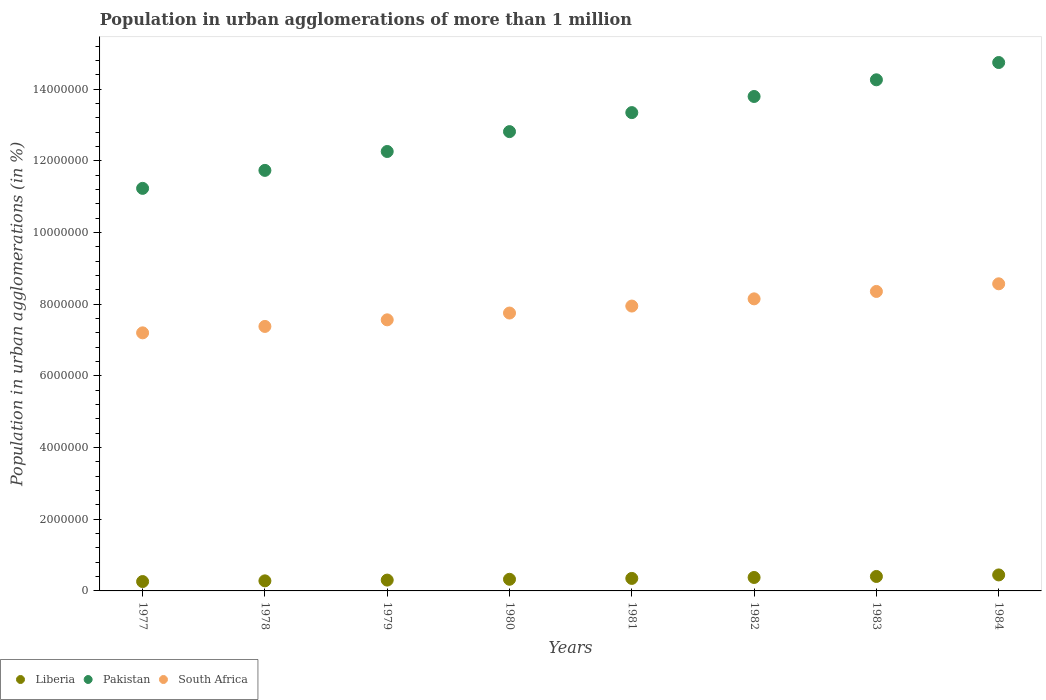What is the population in urban agglomerations in Liberia in 1978?
Ensure brevity in your answer.  2.81e+05. Across all years, what is the maximum population in urban agglomerations in Pakistan?
Your answer should be very brief. 1.47e+07. Across all years, what is the minimum population in urban agglomerations in South Africa?
Your answer should be compact. 7.20e+06. In which year was the population in urban agglomerations in Liberia maximum?
Keep it short and to the point. 1984. In which year was the population in urban agglomerations in South Africa minimum?
Ensure brevity in your answer.  1977. What is the total population in urban agglomerations in South Africa in the graph?
Your answer should be compact. 6.29e+07. What is the difference between the population in urban agglomerations in Pakistan in 1983 and that in 1984?
Your response must be concise. -4.82e+05. What is the difference between the population in urban agglomerations in South Africa in 1983 and the population in urban agglomerations in Liberia in 1977?
Offer a terse response. 8.10e+06. What is the average population in urban agglomerations in Pakistan per year?
Your answer should be very brief. 1.30e+07. In the year 1983, what is the difference between the population in urban agglomerations in Pakistan and population in urban agglomerations in South Africa?
Your answer should be very brief. 5.91e+06. What is the ratio of the population in urban agglomerations in Liberia in 1979 to that in 1982?
Keep it short and to the point. 0.8. Is the difference between the population in urban agglomerations in Pakistan in 1980 and 1983 greater than the difference between the population in urban agglomerations in South Africa in 1980 and 1983?
Your answer should be compact. No. What is the difference between the highest and the second highest population in urban agglomerations in South Africa?
Ensure brevity in your answer.  2.13e+05. What is the difference between the highest and the lowest population in urban agglomerations in South Africa?
Provide a succinct answer. 1.37e+06. In how many years, is the population in urban agglomerations in Liberia greater than the average population in urban agglomerations in Liberia taken over all years?
Offer a very short reply. 4. Is the sum of the population in urban agglomerations in Liberia in 1977 and 1978 greater than the maximum population in urban agglomerations in South Africa across all years?
Your answer should be very brief. No. Is it the case that in every year, the sum of the population in urban agglomerations in South Africa and population in urban agglomerations in Pakistan  is greater than the population in urban agglomerations in Liberia?
Offer a terse response. Yes. How many years are there in the graph?
Your response must be concise. 8. What is the difference between two consecutive major ticks on the Y-axis?
Ensure brevity in your answer.  2.00e+06. Does the graph contain any zero values?
Provide a succinct answer. No. How many legend labels are there?
Make the answer very short. 3. What is the title of the graph?
Provide a succinct answer. Population in urban agglomerations of more than 1 million. Does "Gambia, The" appear as one of the legend labels in the graph?
Provide a short and direct response. No. What is the label or title of the X-axis?
Your response must be concise. Years. What is the label or title of the Y-axis?
Ensure brevity in your answer.  Population in urban agglomerations (in %). What is the Population in urban agglomerations (in %) of Liberia in 1977?
Offer a very short reply. 2.61e+05. What is the Population in urban agglomerations (in %) in Pakistan in 1977?
Provide a succinct answer. 1.12e+07. What is the Population in urban agglomerations (in %) of South Africa in 1977?
Provide a succinct answer. 7.20e+06. What is the Population in urban agglomerations (in %) of Liberia in 1978?
Give a very brief answer. 2.81e+05. What is the Population in urban agglomerations (in %) of Pakistan in 1978?
Your answer should be compact. 1.17e+07. What is the Population in urban agglomerations (in %) in South Africa in 1978?
Provide a succinct answer. 7.38e+06. What is the Population in urban agglomerations (in %) of Liberia in 1979?
Your response must be concise. 3.02e+05. What is the Population in urban agglomerations (in %) in Pakistan in 1979?
Provide a short and direct response. 1.23e+07. What is the Population in urban agglomerations (in %) in South Africa in 1979?
Offer a very short reply. 7.56e+06. What is the Population in urban agglomerations (in %) of Liberia in 1980?
Keep it short and to the point. 3.25e+05. What is the Population in urban agglomerations (in %) in Pakistan in 1980?
Give a very brief answer. 1.28e+07. What is the Population in urban agglomerations (in %) in South Africa in 1980?
Offer a terse response. 7.75e+06. What is the Population in urban agglomerations (in %) of Liberia in 1981?
Make the answer very short. 3.49e+05. What is the Population in urban agglomerations (in %) of Pakistan in 1981?
Ensure brevity in your answer.  1.33e+07. What is the Population in urban agglomerations (in %) in South Africa in 1981?
Your answer should be compact. 7.95e+06. What is the Population in urban agglomerations (in %) in Liberia in 1982?
Make the answer very short. 3.75e+05. What is the Population in urban agglomerations (in %) in Pakistan in 1982?
Offer a terse response. 1.38e+07. What is the Population in urban agglomerations (in %) of South Africa in 1982?
Your answer should be very brief. 8.15e+06. What is the Population in urban agglomerations (in %) in Liberia in 1983?
Your answer should be compact. 4.03e+05. What is the Population in urban agglomerations (in %) in Pakistan in 1983?
Provide a succinct answer. 1.43e+07. What is the Population in urban agglomerations (in %) in South Africa in 1983?
Give a very brief answer. 8.36e+06. What is the Population in urban agglomerations (in %) in Liberia in 1984?
Ensure brevity in your answer.  4.46e+05. What is the Population in urban agglomerations (in %) in Pakistan in 1984?
Ensure brevity in your answer.  1.47e+07. What is the Population in urban agglomerations (in %) in South Africa in 1984?
Your answer should be compact. 8.57e+06. Across all years, what is the maximum Population in urban agglomerations (in %) of Liberia?
Provide a short and direct response. 4.46e+05. Across all years, what is the maximum Population in urban agglomerations (in %) in Pakistan?
Provide a succinct answer. 1.47e+07. Across all years, what is the maximum Population in urban agglomerations (in %) of South Africa?
Your answer should be compact. 8.57e+06. Across all years, what is the minimum Population in urban agglomerations (in %) of Liberia?
Keep it short and to the point. 2.61e+05. Across all years, what is the minimum Population in urban agglomerations (in %) in Pakistan?
Give a very brief answer. 1.12e+07. Across all years, what is the minimum Population in urban agglomerations (in %) in South Africa?
Keep it short and to the point. 7.20e+06. What is the total Population in urban agglomerations (in %) of Liberia in the graph?
Your answer should be very brief. 2.74e+06. What is the total Population in urban agglomerations (in %) of Pakistan in the graph?
Ensure brevity in your answer.  1.04e+08. What is the total Population in urban agglomerations (in %) of South Africa in the graph?
Provide a short and direct response. 6.29e+07. What is the difference between the Population in urban agglomerations (in %) in Liberia in 1977 and that in 1978?
Keep it short and to the point. -1.96e+04. What is the difference between the Population in urban agglomerations (in %) of Pakistan in 1977 and that in 1978?
Provide a succinct answer. -5.02e+05. What is the difference between the Population in urban agglomerations (in %) of South Africa in 1977 and that in 1978?
Keep it short and to the point. -1.79e+05. What is the difference between the Population in urban agglomerations (in %) of Liberia in 1977 and that in 1979?
Your response must be concise. -4.07e+04. What is the difference between the Population in urban agglomerations (in %) of Pakistan in 1977 and that in 1979?
Offer a very short reply. -1.03e+06. What is the difference between the Population in urban agglomerations (in %) in South Africa in 1977 and that in 1979?
Your answer should be very brief. -3.63e+05. What is the difference between the Population in urban agglomerations (in %) of Liberia in 1977 and that in 1980?
Offer a terse response. -6.34e+04. What is the difference between the Population in urban agglomerations (in %) in Pakistan in 1977 and that in 1980?
Your answer should be compact. -1.58e+06. What is the difference between the Population in urban agglomerations (in %) of South Africa in 1977 and that in 1980?
Your response must be concise. -5.53e+05. What is the difference between the Population in urban agglomerations (in %) in Liberia in 1977 and that in 1981?
Give a very brief answer. -8.77e+04. What is the difference between the Population in urban agglomerations (in %) of Pakistan in 1977 and that in 1981?
Offer a very short reply. -2.11e+06. What is the difference between the Population in urban agglomerations (in %) in South Africa in 1977 and that in 1981?
Your answer should be very brief. -7.48e+05. What is the difference between the Population in urban agglomerations (in %) in Liberia in 1977 and that in 1982?
Your response must be concise. -1.14e+05. What is the difference between the Population in urban agglomerations (in %) in Pakistan in 1977 and that in 1982?
Provide a succinct answer. -2.56e+06. What is the difference between the Population in urban agglomerations (in %) in South Africa in 1977 and that in 1982?
Ensure brevity in your answer.  -9.49e+05. What is the difference between the Population in urban agglomerations (in %) in Liberia in 1977 and that in 1983?
Your answer should be very brief. -1.42e+05. What is the difference between the Population in urban agglomerations (in %) of Pakistan in 1977 and that in 1983?
Your answer should be compact. -3.03e+06. What is the difference between the Population in urban agglomerations (in %) of South Africa in 1977 and that in 1983?
Your answer should be very brief. -1.16e+06. What is the difference between the Population in urban agglomerations (in %) in Liberia in 1977 and that in 1984?
Provide a short and direct response. -1.85e+05. What is the difference between the Population in urban agglomerations (in %) in Pakistan in 1977 and that in 1984?
Offer a very short reply. -3.51e+06. What is the difference between the Population in urban agglomerations (in %) in South Africa in 1977 and that in 1984?
Offer a terse response. -1.37e+06. What is the difference between the Population in urban agglomerations (in %) in Liberia in 1978 and that in 1979?
Offer a terse response. -2.11e+04. What is the difference between the Population in urban agglomerations (in %) in Pakistan in 1978 and that in 1979?
Keep it short and to the point. -5.27e+05. What is the difference between the Population in urban agglomerations (in %) in South Africa in 1978 and that in 1979?
Your answer should be very brief. -1.84e+05. What is the difference between the Population in urban agglomerations (in %) of Liberia in 1978 and that in 1980?
Ensure brevity in your answer.  -4.38e+04. What is the difference between the Population in urban agglomerations (in %) of Pakistan in 1978 and that in 1980?
Make the answer very short. -1.08e+06. What is the difference between the Population in urban agglomerations (in %) in South Africa in 1978 and that in 1980?
Provide a succinct answer. -3.74e+05. What is the difference between the Population in urban agglomerations (in %) of Liberia in 1978 and that in 1981?
Offer a terse response. -6.81e+04. What is the difference between the Population in urban agglomerations (in %) of Pakistan in 1978 and that in 1981?
Ensure brevity in your answer.  -1.61e+06. What is the difference between the Population in urban agglomerations (in %) of South Africa in 1978 and that in 1981?
Make the answer very short. -5.69e+05. What is the difference between the Population in urban agglomerations (in %) of Liberia in 1978 and that in 1982?
Provide a succinct answer. -9.43e+04. What is the difference between the Population in urban agglomerations (in %) in Pakistan in 1978 and that in 1982?
Provide a short and direct response. -2.06e+06. What is the difference between the Population in urban agglomerations (in %) in South Africa in 1978 and that in 1982?
Provide a succinct answer. -7.70e+05. What is the difference between the Population in urban agglomerations (in %) in Liberia in 1978 and that in 1983?
Provide a short and direct response. -1.22e+05. What is the difference between the Population in urban agglomerations (in %) of Pakistan in 1978 and that in 1983?
Ensure brevity in your answer.  -2.53e+06. What is the difference between the Population in urban agglomerations (in %) of South Africa in 1978 and that in 1983?
Your answer should be very brief. -9.76e+05. What is the difference between the Population in urban agglomerations (in %) of Liberia in 1978 and that in 1984?
Give a very brief answer. -1.65e+05. What is the difference between the Population in urban agglomerations (in %) in Pakistan in 1978 and that in 1984?
Your response must be concise. -3.01e+06. What is the difference between the Population in urban agglomerations (in %) in South Africa in 1978 and that in 1984?
Offer a very short reply. -1.19e+06. What is the difference between the Population in urban agglomerations (in %) in Liberia in 1979 and that in 1980?
Keep it short and to the point. -2.27e+04. What is the difference between the Population in urban agglomerations (in %) of Pakistan in 1979 and that in 1980?
Provide a short and direct response. -5.55e+05. What is the difference between the Population in urban agglomerations (in %) in South Africa in 1979 and that in 1980?
Offer a terse response. -1.90e+05. What is the difference between the Population in urban agglomerations (in %) of Liberia in 1979 and that in 1981?
Offer a terse response. -4.70e+04. What is the difference between the Population in urban agglomerations (in %) in Pakistan in 1979 and that in 1981?
Offer a very short reply. -1.09e+06. What is the difference between the Population in urban agglomerations (in %) of South Africa in 1979 and that in 1981?
Offer a terse response. -3.85e+05. What is the difference between the Population in urban agglomerations (in %) in Liberia in 1979 and that in 1982?
Your answer should be compact. -7.32e+04. What is the difference between the Population in urban agglomerations (in %) in Pakistan in 1979 and that in 1982?
Offer a very short reply. -1.54e+06. What is the difference between the Population in urban agglomerations (in %) in South Africa in 1979 and that in 1982?
Offer a very short reply. -5.85e+05. What is the difference between the Population in urban agglomerations (in %) in Liberia in 1979 and that in 1983?
Your response must be concise. -1.01e+05. What is the difference between the Population in urban agglomerations (in %) of Pakistan in 1979 and that in 1983?
Offer a terse response. -2.00e+06. What is the difference between the Population in urban agglomerations (in %) of South Africa in 1979 and that in 1983?
Provide a short and direct response. -7.92e+05. What is the difference between the Population in urban agglomerations (in %) in Liberia in 1979 and that in 1984?
Provide a succinct answer. -1.44e+05. What is the difference between the Population in urban agglomerations (in %) of Pakistan in 1979 and that in 1984?
Your response must be concise. -2.48e+06. What is the difference between the Population in urban agglomerations (in %) of South Africa in 1979 and that in 1984?
Provide a succinct answer. -1.01e+06. What is the difference between the Population in urban agglomerations (in %) in Liberia in 1980 and that in 1981?
Give a very brief answer. -2.43e+04. What is the difference between the Population in urban agglomerations (in %) in Pakistan in 1980 and that in 1981?
Provide a short and direct response. -5.31e+05. What is the difference between the Population in urban agglomerations (in %) in South Africa in 1980 and that in 1981?
Ensure brevity in your answer.  -1.95e+05. What is the difference between the Population in urban agglomerations (in %) in Liberia in 1980 and that in 1982?
Provide a succinct answer. -5.05e+04. What is the difference between the Population in urban agglomerations (in %) in Pakistan in 1980 and that in 1982?
Your answer should be compact. -9.81e+05. What is the difference between the Population in urban agglomerations (in %) in South Africa in 1980 and that in 1982?
Give a very brief answer. -3.96e+05. What is the difference between the Population in urban agglomerations (in %) of Liberia in 1980 and that in 1983?
Your response must be concise. -7.87e+04. What is the difference between the Population in urban agglomerations (in %) of Pakistan in 1980 and that in 1983?
Offer a terse response. -1.45e+06. What is the difference between the Population in urban agglomerations (in %) of South Africa in 1980 and that in 1983?
Provide a succinct answer. -6.02e+05. What is the difference between the Population in urban agglomerations (in %) in Liberia in 1980 and that in 1984?
Provide a short and direct response. -1.22e+05. What is the difference between the Population in urban agglomerations (in %) in Pakistan in 1980 and that in 1984?
Your answer should be very brief. -1.93e+06. What is the difference between the Population in urban agglomerations (in %) in South Africa in 1980 and that in 1984?
Your response must be concise. -8.16e+05. What is the difference between the Population in urban agglomerations (in %) of Liberia in 1981 and that in 1982?
Give a very brief answer. -2.62e+04. What is the difference between the Population in urban agglomerations (in %) in Pakistan in 1981 and that in 1982?
Your answer should be compact. -4.50e+05. What is the difference between the Population in urban agglomerations (in %) in South Africa in 1981 and that in 1982?
Give a very brief answer. -2.01e+05. What is the difference between the Population in urban agglomerations (in %) of Liberia in 1981 and that in 1983?
Ensure brevity in your answer.  -5.44e+04. What is the difference between the Population in urban agglomerations (in %) of Pakistan in 1981 and that in 1983?
Offer a very short reply. -9.15e+05. What is the difference between the Population in urban agglomerations (in %) of South Africa in 1981 and that in 1983?
Your answer should be compact. -4.08e+05. What is the difference between the Population in urban agglomerations (in %) of Liberia in 1981 and that in 1984?
Keep it short and to the point. -9.72e+04. What is the difference between the Population in urban agglomerations (in %) of Pakistan in 1981 and that in 1984?
Give a very brief answer. -1.40e+06. What is the difference between the Population in urban agglomerations (in %) in South Africa in 1981 and that in 1984?
Give a very brief answer. -6.21e+05. What is the difference between the Population in urban agglomerations (in %) of Liberia in 1982 and that in 1983?
Ensure brevity in your answer.  -2.82e+04. What is the difference between the Population in urban agglomerations (in %) of Pakistan in 1982 and that in 1983?
Your answer should be compact. -4.65e+05. What is the difference between the Population in urban agglomerations (in %) of South Africa in 1982 and that in 1983?
Provide a succinct answer. -2.07e+05. What is the difference between the Population in urban agglomerations (in %) of Liberia in 1982 and that in 1984?
Offer a terse response. -7.10e+04. What is the difference between the Population in urban agglomerations (in %) of Pakistan in 1982 and that in 1984?
Ensure brevity in your answer.  -9.47e+05. What is the difference between the Population in urban agglomerations (in %) of South Africa in 1982 and that in 1984?
Make the answer very short. -4.20e+05. What is the difference between the Population in urban agglomerations (in %) in Liberia in 1983 and that in 1984?
Keep it short and to the point. -4.28e+04. What is the difference between the Population in urban agglomerations (in %) in Pakistan in 1983 and that in 1984?
Provide a succinct answer. -4.82e+05. What is the difference between the Population in urban agglomerations (in %) in South Africa in 1983 and that in 1984?
Ensure brevity in your answer.  -2.13e+05. What is the difference between the Population in urban agglomerations (in %) of Liberia in 1977 and the Population in urban agglomerations (in %) of Pakistan in 1978?
Make the answer very short. -1.15e+07. What is the difference between the Population in urban agglomerations (in %) in Liberia in 1977 and the Population in urban agglomerations (in %) in South Africa in 1978?
Ensure brevity in your answer.  -7.12e+06. What is the difference between the Population in urban agglomerations (in %) in Pakistan in 1977 and the Population in urban agglomerations (in %) in South Africa in 1978?
Keep it short and to the point. 3.85e+06. What is the difference between the Population in urban agglomerations (in %) in Liberia in 1977 and the Population in urban agglomerations (in %) in Pakistan in 1979?
Keep it short and to the point. -1.20e+07. What is the difference between the Population in urban agglomerations (in %) of Liberia in 1977 and the Population in urban agglomerations (in %) of South Africa in 1979?
Your answer should be compact. -7.30e+06. What is the difference between the Population in urban agglomerations (in %) in Pakistan in 1977 and the Population in urban agglomerations (in %) in South Africa in 1979?
Offer a terse response. 3.67e+06. What is the difference between the Population in urban agglomerations (in %) of Liberia in 1977 and the Population in urban agglomerations (in %) of Pakistan in 1980?
Provide a short and direct response. -1.26e+07. What is the difference between the Population in urban agglomerations (in %) in Liberia in 1977 and the Population in urban agglomerations (in %) in South Africa in 1980?
Ensure brevity in your answer.  -7.49e+06. What is the difference between the Population in urban agglomerations (in %) in Pakistan in 1977 and the Population in urban agglomerations (in %) in South Africa in 1980?
Your answer should be compact. 3.48e+06. What is the difference between the Population in urban agglomerations (in %) in Liberia in 1977 and the Population in urban agglomerations (in %) in Pakistan in 1981?
Provide a short and direct response. -1.31e+07. What is the difference between the Population in urban agglomerations (in %) in Liberia in 1977 and the Population in urban agglomerations (in %) in South Africa in 1981?
Provide a succinct answer. -7.69e+06. What is the difference between the Population in urban agglomerations (in %) of Pakistan in 1977 and the Population in urban agglomerations (in %) of South Africa in 1981?
Your answer should be very brief. 3.28e+06. What is the difference between the Population in urban agglomerations (in %) of Liberia in 1977 and the Population in urban agglomerations (in %) of Pakistan in 1982?
Your answer should be compact. -1.35e+07. What is the difference between the Population in urban agglomerations (in %) of Liberia in 1977 and the Population in urban agglomerations (in %) of South Africa in 1982?
Your response must be concise. -7.89e+06. What is the difference between the Population in urban agglomerations (in %) in Pakistan in 1977 and the Population in urban agglomerations (in %) in South Africa in 1982?
Ensure brevity in your answer.  3.08e+06. What is the difference between the Population in urban agglomerations (in %) in Liberia in 1977 and the Population in urban agglomerations (in %) in Pakistan in 1983?
Your answer should be very brief. -1.40e+07. What is the difference between the Population in urban agglomerations (in %) in Liberia in 1977 and the Population in urban agglomerations (in %) in South Africa in 1983?
Offer a terse response. -8.10e+06. What is the difference between the Population in urban agglomerations (in %) in Pakistan in 1977 and the Population in urban agglomerations (in %) in South Africa in 1983?
Make the answer very short. 2.88e+06. What is the difference between the Population in urban agglomerations (in %) in Liberia in 1977 and the Population in urban agglomerations (in %) in Pakistan in 1984?
Your answer should be compact. -1.45e+07. What is the difference between the Population in urban agglomerations (in %) of Liberia in 1977 and the Population in urban agglomerations (in %) of South Africa in 1984?
Your answer should be very brief. -8.31e+06. What is the difference between the Population in urban agglomerations (in %) in Pakistan in 1977 and the Population in urban agglomerations (in %) in South Africa in 1984?
Your answer should be compact. 2.66e+06. What is the difference between the Population in urban agglomerations (in %) of Liberia in 1978 and the Population in urban agglomerations (in %) of Pakistan in 1979?
Ensure brevity in your answer.  -1.20e+07. What is the difference between the Population in urban agglomerations (in %) of Liberia in 1978 and the Population in urban agglomerations (in %) of South Africa in 1979?
Provide a short and direct response. -7.28e+06. What is the difference between the Population in urban agglomerations (in %) of Pakistan in 1978 and the Population in urban agglomerations (in %) of South Africa in 1979?
Your answer should be compact. 4.17e+06. What is the difference between the Population in urban agglomerations (in %) in Liberia in 1978 and the Population in urban agglomerations (in %) in Pakistan in 1980?
Your answer should be very brief. -1.25e+07. What is the difference between the Population in urban agglomerations (in %) in Liberia in 1978 and the Population in urban agglomerations (in %) in South Africa in 1980?
Make the answer very short. -7.47e+06. What is the difference between the Population in urban agglomerations (in %) in Pakistan in 1978 and the Population in urban agglomerations (in %) in South Africa in 1980?
Ensure brevity in your answer.  3.98e+06. What is the difference between the Population in urban agglomerations (in %) of Liberia in 1978 and the Population in urban agglomerations (in %) of Pakistan in 1981?
Ensure brevity in your answer.  -1.31e+07. What is the difference between the Population in urban agglomerations (in %) in Liberia in 1978 and the Population in urban agglomerations (in %) in South Africa in 1981?
Give a very brief answer. -7.67e+06. What is the difference between the Population in urban agglomerations (in %) of Pakistan in 1978 and the Population in urban agglomerations (in %) of South Africa in 1981?
Make the answer very short. 3.79e+06. What is the difference between the Population in urban agglomerations (in %) of Liberia in 1978 and the Population in urban agglomerations (in %) of Pakistan in 1982?
Offer a terse response. -1.35e+07. What is the difference between the Population in urban agglomerations (in %) of Liberia in 1978 and the Population in urban agglomerations (in %) of South Africa in 1982?
Your answer should be very brief. -7.87e+06. What is the difference between the Population in urban agglomerations (in %) of Pakistan in 1978 and the Population in urban agglomerations (in %) of South Africa in 1982?
Make the answer very short. 3.59e+06. What is the difference between the Population in urban agglomerations (in %) of Liberia in 1978 and the Population in urban agglomerations (in %) of Pakistan in 1983?
Make the answer very short. -1.40e+07. What is the difference between the Population in urban agglomerations (in %) in Liberia in 1978 and the Population in urban agglomerations (in %) in South Africa in 1983?
Make the answer very short. -8.08e+06. What is the difference between the Population in urban agglomerations (in %) in Pakistan in 1978 and the Population in urban agglomerations (in %) in South Africa in 1983?
Your answer should be very brief. 3.38e+06. What is the difference between the Population in urban agglomerations (in %) of Liberia in 1978 and the Population in urban agglomerations (in %) of Pakistan in 1984?
Provide a succinct answer. -1.45e+07. What is the difference between the Population in urban agglomerations (in %) of Liberia in 1978 and the Population in urban agglomerations (in %) of South Africa in 1984?
Provide a short and direct response. -8.29e+06. What is the difference between the Population in urban agglomerations (in %) in Pakistan in 1978 and the Population in urban agglomerations (in %) in South Africa in 1984?
Offer a very short reply. 3.17e+06. What is the difference between the Population in urban agglomerations (in %) in Liberia in 1979 and the Population in urban agglomerations (in %) in Pakistan in 1980?
Provide a short and direct response. -1.25e+07. What is the difference between the Population in urban agglomerations (in %) in Liberia in 1979 and the Population in urban agglomerations (in %) in South Africa in 1980?
Keep it short and to the point. -7.45e+06. What is the difference between the Population in urban agglomerations (in %) of Pakistan in 1979 and the Population in urban agglomerations (in %) of South Africa in 1980?
Your response must be concise. 4.51e+06. What is the difference between the Population in urban agglomerations (in %) in Liberia in 1979 and the Population in urban agglomerations (in %) in Pakistan in 1981?
Ensure brevity in your answer.  -1.30e+07. What is the difference between the Population in urban agglomerations (in %) in Liberia in 1979 and the Population in urban agglomerations (in %) in South Africa in 1981?
Provide a short and direct response. -7.65e+06. What is the difference between the Population in urban agglomerations (in %) of Pakistan in 1979 and the Population in urban agglomerations (in %) of South Africa in 1981?
Your answer should be very brief. 4.31e+06. What is the difference between the Population in urban agglomerations (in %) in Liberia in 1979 and the Population in urban agglomerations (in %) in Pakistan in 1982?
Your answer should be very brief. -1.35e+07. What is the difference between the Population in urban agglomerations (in %) in Liberia in 1979 and the Population in urban agglomerations (in %) in South Africa in 1982?
Give a very brief answer. -7.85e+06. What is the difference between the Population in urban agglomerations (in %) of Pakistan in 1979 and the Population in urban agglomerations (in %) of South Africa in 1982?
Keep it short and to the point. 4.11e+06. What is the difference between the Population in urban agglomerations (in %) of Liberia in 1979 and the Population in urban agglomerations (in %) of Pakistan in 1983?
Your answer should be compact. -1.40e+07. What is the difference between the Population in urban agglomerations (in %) of Liberia in 1979 and the Population in urban agglomerations (in %) of South Africa in 1983?
Your answer should be compact. -8.06e+06. What is the difference between the Population in urban agglomerations (in %) of Pakistan in 1979 and the Population in urban agglomerations (in %) of South Africa in 1983?
Your answer should be compact. 3.91e+06. What is the difference between the Population in urban agglomerations (in %) of Liberia in 1979 and the Population in urban agglomerations (in %) of Pakistan in 1984?
Your answer should be compact. -1.44e+07. What is the difference between the Population in urban agglomerations (in %) in Liberia in 1979 and the Population in urban agglomerations (in %) in South Africa in 1984?
Your response must be concise. -8.27e+06. What is the difference between the Population in urban agglomerations (in %) in Pakistan in 1979 and the Population in urban agglomerations (in %) in South Africa in 1984?
Provide a succinct answer. 3.69e+06. What is the difference between the Population in urban agglomerations (in %) in Liberia in 1980 and the Population in urban agglomerations (in %) in Pakistan in 1981?
Give a very brief answer. -1.30e+07. What is the difference between the Population in urban agglomerations (in %) of Liberia in 1980 and the Population in urban agglomerations (in %) of South Africa in 1981?
Offer a very short reply. -7.62e+06. What is the difference between the Population in urban agglomerations (in %) in Pakistan in 1980 and the Population in urban agglomerations (in %) in South Africa in 1981?
Offer a terse response. 4.87e+06. What is the difference between the Population in urban agglomerations (in %) in Liberia in 1980 and the Population in urban agglomerations (in %) in Pakistan in 1982?
Provide a succinct answer. -1.35e+07. What is the difference between the Population in urban agglomerations (in %) in Liberia in 1980 and the Population in urban agglomerations (in %) in South Africa in 1982?
Keep it short and to the point. -7.83e+06. What is the difference between the Population in urban agglomerations (in %) in Pakistan in 1980 and the Population in urban agglomerations (in %) in South Africa in 1982?
Make the answer very short. 4.67e+06. What is the difference between the Population in urban agglomerations (in %) of Liberia in 1980 and the Population in urban agglomerations (in %) of Pakistan in 1983?
Provide a succinct answer. -1.39e+07. What is the difference between the Population in urban agglomerations (in %) in Liberia in 1980 and the Population in urban agglomerations (in %) in South Africa in 1983?
Give a very brief answer. -8.03e+06. What is the difference between the Population in urban agglomerations (in %) in Pakistan in 1980 and the Population in urban agglomerations (in %) in South Africa in 1983?
Ensure brevity in your answer.  4.46e+06. What is the difference between the Population in urban agglomerations (in %) of Liberia in 1980 and the Population in urban agglomerations (in %) of Pakistan in 1984?
Keep it short and to the point. -1.44e+07. What is the difference between the Population in urban agglomerations (in %) in Liberia in 1980 and the Population in urban agglomerations (in %) in South Africa in 1984?
Offer a very short reply. -8.25e+06. What is the difference between the Population in urban agglomerations (in %) of Pakistan in 1980 and the Population in urban agglomerations (in %) of South Africa in 1984?
Ensure brevity in your answer.  4.25e+06. What is the difference between the Population in urban agglomerations (in %) in Liberia in 1981 and the Population in urban agglomerations (in %) in Pakistan in 1982?
Provide a succinct answer. -1.34e+07. What is the difference between the Population in urban agglomerations (in %) in Liberia in 1981 and the Population in urban agglomerations (in %) in South Africa in 1982?
Ensure brevity in your answer.  -7.80e+06. What is the difference between the Population in urban agglomerations (in %) of Pakistan in 1981 and the Population in urban agglomerations (in %) of South Africa in 1982?
Keep it short and to the point. 5.20e+06. What is the difference between the Population in urban agglomerations (in %) in Liberia in 1981 and the Population in urban agglomerations (in %) in Pakistan in 1983?
Keep it short and to the point. -1.39e+07. What is the difference between the Population in urban agglomerations (in %) in Liberia in 1981 and the Population in urban agglomerations (in %) in South Africa in 1983?
Your answer should be very brief. -8.01e+06. What is the difference between the Population in urban agglomerations (in %) in Pakistan in 1981 and the Population in urban agglomerations (in %) in South Africa in 1983?
Ensure brevity in your answer.  4.99e+06. What is the difference between the Population in urban agglomerations (in %) in Liberia in 1981 and the Population in urban agglomerations (in %) in Pakistan in 1984?
Offer a terse response. -1.44e+07. What is the difference between the Population in urban agglomerations (in %) of Liberia in 1981 and the Population in urban agglomerations (in %) of South Africa in 1984?
Ensure brevity in your answer.  -8.22e+06. What is the difference between the Population in urban agglomerations (in %) in Pakistan in 1981 and the Population in urban agglomerations (in %) in South Africa in 1984?
Provide a short and direct response. 4.78e+06. What is the difference between the Population in urban agglomerations (in %) in Liberia in 1982 and the Population in urban agglomerations (in %) in Pakistan in 1983?
Provide a succinct answer. -1.39e+07. What is the difference between the Population in urban agglomerations (in %) of Liberia in 1982 and the Population in urban agglomerations (in %) of South Africa in 1983?
Provide a succinct answer. -7.98e+06. What is the difference between the Population in urban agglomerations (in %) of Pakistan in 1982 and the Population in urban agglomerations (in %) of South Africa in 1983?
Your answer should be compact. 5.44e+06. What is the difference between the Population in urban agglomerations (in %) in Liberia in 1982 and the Population in urban agglomerations (in %) in Pakistan in 1984?
Offer a terse response. -1.44e+07. What is the difference between the Population in urban agglomerations (in %) of Liberia in 1982 and the Population in urban agglomerations (in %) of South Africa in 1984?
Provide a succinct answer. -8.20e+06. What is the difference between the Population in urban agglomerations (in %) of Pakistan in 1982 and the Population in urban agglomerations (in %) of South Africa in 1984?
Your answer should be very brief. 5.23e+06. What is the difference between the Population in urban agglomerations (in %) of Liberia in 1983 and the Population in urban agglomerations (in %) of Pakistan in 1984?
Offer a very short reply. -1.43e+07. What is the difference between the Population in urban agglomerations (in %) of Liberia in 1983 and the Population in urban agglomerations (in %) of South Africa in 1984?
Keep it short and to the point. -8.17e+06. What is the difference between the Population in urban agglomerations (in %) in Pakistan in 1983 and the Population in urban agglomerations (in %) in South Africa in 1984?
Keep it short and to the point. 5.69e+06. What is the average Population in urban agglomerations (in %) in Liberia per year?
Offer a very short reply. 3.43e+05. What is the average Population in urban agglomerations (in %) in Pakistan per year?
Provide a succinct answer. 1.30e+07. What is the average Population in urban agglomerations (in %) in South Africa per year?
Provide a succinct answer. 7.87e+06. In the year 1977, what is the difference between the Population in urban agglomerations (in %) of Liberia and Population in urban agglomerations (in %) of Pakistan?
Give a very brief answer. -1.10e+07. In the year 1977, what is the difference between the Population in urban agglomerations (in %) of Liberia and Population in urban agglomerations (in %) of South Africa?
Offer a very short reply. -6.94e+06. In the year 1977, what is the difference between the Population in urban agglomerations (in %) of Pakistan and Population in urban agglomerations (in %) of South Africa?
Ensure brevity in your answer.  4.03e+06. In the year 1978, what is the difference between the Population in urban agglomerations (in %) in Liberia and Population in urban agglomerations (in %) in Pakistan?
Provide a succinct answer. -1.15e+07. In the year 1978, what is the difference between the Population in urban agglomerations (in %) in Liberia and Population in urban agglomerations (in %) in South Africa?
Make the answer very short. -7.10e+06. In the year 1978, what is the difference between the Population in urban agglomerations (in %) in Pakistan and Population in urban agglomerations (in %) in South Africa?
Provide a short and direct response. 4.35e+06. In the year 1979, what is the difference between the Population in urban agglomerations (in %) of Liberia and Population in urban agglomerations (in %) of Pakistan?
Keep it short and to the point. -1.20e+07. In the year 1979, what is the difference between the Population in urban agglomerations (in %) in Liberia and Population in urban agglomerations (in %) in South Africa?
Make the answer very short. -7.26e+06. In the year 1979, what is the difference between the Population in urban agglomerations (in %) of Pakistan and Population in urban agglomerations (in %) of South Africa?
Make the answer very short. 4.70e+06. In the year 1980, what is the difference between the Population in urban agglomerations (in %) of Liberia and Population in urban agglomerations (in %) of Pakistan?
Provide a succinct answer. -1.25e+07. In the year 1980, what is the difference between the Population in urban agglomerations (in %) of Liberia and Population in urban agglomerations (in %) of South Africa?
Your answer should be very brief. -7.43e+06. In the year 1980, what is the difference between the Population in urban agglomerations (in %) in Pakistan and Population in urban agglomerations (in %) in South Africa?
Provide a short and direct response. 5.06e+06. In the year 1981, what is the difference between the Population in urban agglomerations (in %) of Liberia and Population in urban agglomerations (in %) of Pakistan?
Offer a very short reply. -1.30e+07. In the year 1981, what is the difference between the Population in urban agglomerations (in %) in Liberia and Population in urban agglomerations (in %) in South Africa?
Provide a short and direct response. -7.60e+06. In the year 1981, what is the difference between the Population in urban agglomerations (in %) of Pakistan and Population in urban agglomerations (in %) of South Africa?
Your response must be concise. 5.40e+06. In the year 1982, what is the difference between the Population in urban agglomerations (in %) in Liberia and Population in urban agglomerations (in %) in Pakistan?
Your answer should be compact. -1.34e+07. In the year 1982, what is the difference between the Population in urban agglomerations (in %) of Liberia and Population in urban agglomerations (in %) of South Africa?
Your answer should be compact. -7.78e+06. In the year 1982, what is the difference between the Population in urban agglomerations (in %) of Pakistan and Population in urban agglomerations (in %) of South Africa?
Provide a succinct answer. 5.65e+06. In the year 1983, what is the difference between the Population in urban agglomerations (in %) of Liberia and Population in urban agglomerations (in %) of Pakistan?
Provide a succinct answer. -1.39e+07. In the year 1983, what is the difference between the Population in urban agglomerations (in %) in Liberia and Population in urban agglomerations (in %) in South Africa?
Make the answer very short. -7.95e+06. In the year 1983, what is the difference between the Population in urban agglomerations (in %) in Pakistan and Population in urban agglomerations (in %) in South Africa?
Offer a very short reply. 5.91e+06. In the year 1984, what is the difference between the Population in urban agglomerations (in %) in Liberia and Population in urban agglomerations (in %) in Pakistan?
Offer a very short reply. -1.43e+07. In the year 1984, what is the difference between the Population in urban agglomerations (in %) of Liberia and Population in urban agglomerations (in %) of South Africa?
Offer a very short reply. -8.12e+06. In the year 1984, what is the difference between the Population in urban agglomerations (in %) in Pakistan and Population in urban agglomerations (in %) in South Africa?
Ensure brevity in your answer.  6.18e+06. What is the ratio of the Population in urban agglomerations (in %) in Liberia in 1977 to that in 1978?
Your answer should be very brief. 0.93. What is the ratio of the Population in urban agglomerations (in %) in Pakistan in 1977 to that in 1978?
Give a very brief answer. 0.96. What is the ratio of the Population in urban agglomerations (in %) in South Africa in 1977 to that in 1978?
Give a very brief answer. 0.98. What is the ratio of the Population in urban agglomerations (in %) in Liberia in 1977 to that in 1979?
Keep it short and to the point. 0.87. What is the ratio of the Population in urban agglomerations (in %) of Pakistan in 1977 to that in 1979?
Your answer should be compact. 0.92. What is the ratio of the Population in urban agglomerations (in %) in Liberia in 1977 to that in 1980?
Your answer should be very brief. 0.8. What is the ratio of the Population in urban agglomerations (in %) in Pakistan in 1977 to that in 1980?
Offer a very short reply. 0.88. What is the ratio of the Population in urban agglomerations (in %) of South Africa in 1977 to that in 1980?
Offer a very short reply. 0.93. What is the ratio of the Population in urban agglomerations (in %) of Liberia in 1977 to that in 1981?
Give a very brief answer. 0.75. What is the ratio of the Population in urban agglomerations (in %) in Pakistan in 1977 to that in 1981?
Your answer should be very brief. 0.84. What is the ratio of the Population in urban agglomerations (in %) of South Africa in 1977 to that in 1981?
Offer a very short reply. 0.91. What is the ratio of the Population in urban agglomerations (in %) in Liberia in 1977 to that in 1982?
Make the answer very short. 0.7. What is the ratio of the Population in urban agglomerations (in %) in Pakistan in 1977 to that in 1982?
Make the answer very short. 0.81. What is the ratio of the Population in urban agglomerations (in %) in South Africa in 1977 to that in 1982?
Offer a terse response. 0.88. What is the ratio of the Population in urban agglomerations (in %) in Liberia in 1977 to that in 1983?
Offer a terse response. 0.65. What is the ratio of the Population in urban agglomerations (in %) of Pakistan in 1977 to that in 1983?
Make the answer very short. 0.79. What is the ratio of the Population in urban agglomerations (in %) of South Africa in 1977 to that in 1983?
Your answer should be very brief. 0.86. What is the ratio of the Population in urban agglomerations (in %) of Liberia in 1977 to that in 1984?
Offer a terse response. 0.59. What is the ratio of the Population in urban agglomerations (in %) of Pakistan in 1977 to that in 1984?
Make the answer very short. 0.76. What is the ratio of the Population in urban agglomerations (in %) of South Africa in 1977 to that in 1984?
Offer a terse response. 0.84. What is the ratio of the Population in urban agglomerations (in %) of Liberia in 1978 to that in 1979?
Your answer should be very brief. 0.93. What is the ratio of the Population in urban agglomerations (in %) of Pakistan in 1978 to that in 1979?
Offer a terse response. 0.96. What is the ratio of the Population in urban agglomerations (in %) in South Africa in 1978 to that in 1979?
Provide a short and direct response. 0.98. What is the ratio of the Population in urban agglomerations (in %) of Liberia in 1978 to that in 1980?
Offer a very short reply. 0.87. What is the ratio of the Population in urban agglomerations (in %) of Pakistan in 1978 to that in 1980?
Make the answer very short. 0.92. What is the ratio of the Population in urban agglomerations (in %) in South Africa in 1978 to that in 1980?
Give a very brief answer. 0.95. What is the ratio of the Population in urban agglomerations (in %) in Liberia in 1978 to that in 1981?
Your response must be concise. 0.8. What is the ratio of the Population in urban agglomerations (in %) of Pakistan in 1978 to that in 1981?
Keep it short and to the point. 0.88. What is the ratio of the Population in urban agglomerations (in %) of South Africa in 1978 to that in 1981?
Your answer should be very brief. 0.93. What is the ratio of the Population in urban agglomerations (in %) in Liberia in 1978 to that in 1982?
Keep it short and to the point. 0.75. What is the ratio of the Population in urban agglomerations (in %) of Pakistan in 1978 to that in 1982?
Give a very brief answer. 0.85. What is the ratio of the Population in urban agglomerations (in %) of South Africa in 1978 to that in 1982?
Ensure brevity in your answer.  0.91. What is the ratio of the Population in urban agglomerations (in %) of Liberia in 1978 to that in 1983?
Offer a terse response. 0.7. What is the ratio of the Population in urban agglomerations (in %) in Pakistan in 1978 to that in 1983?
Provide a succinct answer. 0.82. What is the ratio of the Population in urban agglomerations (in %) of South Africa in 1978 to that in 1983?
Provide a succinct answer. 0.88. What is the ratio of the Population in urban agglomerations (in %) of Liberia in 1978 to that in 1984?
Your answer should be compact. 0.63. What is the ratio of the Population in urban agglomerations (in %) of Pakistan in 1978 to that in 1984?
Your answer should be compact. 0.8. What is the ratio of the Population in urban agglomerations (in %) of South Africa in 1978 to that in 1984?
Keep it short and to the point. 0.86. What is the ratio of the Population in urban agglomerations (in %) in Liberia in 1979 to that in 1980?
Keep it short and to the point. 0.93. What is the ratio of the Population in urban agglomerations (in %) in Pakistan in 1979 to that in 1980?
Your answer should be very brief. 0.96. What is the ratio of the Population in urban agglomerations (in %) in South Africa in 1979 to that in 1980?
Your answer should be very brief. 0.98. What is the ratio of the Population in urban agglomerations (in %) of Liberia in 1979 to that in 1981?
Provide a short and direct response. 0.87. What is the ratio of the Population in urban agglomerations (in %) in Pakistan in 1979 to that in 1981?
Provide a short and direct response. 0.92. What is the ratio of the Population in urban agglomerations (in %) in South Africa in 1979 to that in 1981?
Provide a succinct answer. 0.95. What is the ratio of the Population in urban agglomerations (in %) in Liberia in 1979 to that in 1982?
Provide a short and direct response. 0.8. What is the ratio of the Population in urban agglomerations (in %) in Pakistan in 1979 to that in 1982?
Your response must be concise. 0.89. What is the ratio of the Population in urban agglomerations (in %) in South Africa in 1979 to that in 1982?
Your answer should be very brief. 0.93. What is the ratio of the Population in urban agglomerations (in %) of Liberia in 1979 to that in 1983?
Make the answer very short. 0.75. What is the ratio of the Population in urban agglomerations (in %) in Pakistan in 1979 to that in 1983?
Keep it short and to the point. 0.86. What is the ratio of the Population in urban agglomerations (in %) of South Africa in 1979 to that in 1983?
Your answer should be very brief. 0.91. What is the ratio of the Population in urban agglomerations (in %) of Liberia in 1979 to that in 1984?
Ensure brevity in your answer.  0.68. What is the ratio of the Population in urban agglomerations (in %) of Pakistan in 1979 to that in 1984?
Give a very brief answer. 0.83. What is the ratio of the Population in urban agglomerations (in %) of South Africa in 1979 to that in 1984?
Provide a short and direct response. 0.88. What is the ratio of the Population in urban agglomerations (in %) in Liberia in 1980 to that in 1981?
Provide a succinct answer. 0.93. What is the ratio of the Population in urban agglomerations (in %) in Pakistan in 1980 to that in 1981?
Offer a very short reply. 0.96. What is the ratio of the Population in urban agglomerations (in %) in South Africa in 1980 to that in 1981?
Give a very brief answer. 0.98. What is the ratio of the Population in urban agglomerations (in %) in Liberia in 1980 to that in 1982?
Offer a terse response. 0.87. What is the ratio of the Population in urban agglomerations (in %) in Pakistan in 1980 to that in 1982?
Make the answer very short. 0.93. What is the ratio of the Population in urban agglomerations (in %) of South Africa in 1980 to that in 1982?
Your answer should be compact. 0.95. What is the ratio of the Population in urban agglomerations (in %) in Liberia in 1980 to that in 1983?
Ensure brevity in your answer.  0.8. What is the ratio of the Population in urban agglomerations (in %) in Pakistan in 1980 to that in 1983?
Your answer should be very brief. 0.9. What is the ratio of the Population in urban agglomerations (in %) of South Africa in 1980 to that in 1983?
Your answer should be compact. 0.93. What is the ratio of the Population in urban agglomerations (in %) of Liberia in 1980 to that in 1984?
Provide a short and direct response. 0.73. What is the ratio of the Population in urban agglomerations (in %) in Pakistan in 1980 to that in 1984?
Your response must be concise. 0.87. What is the ratio of the Population in urban agglomerations (in %) in South Africa in 1980 to that in 1984?
Keep it short and to the point. 0.9. What is the ratio of the Population in urban agglomerations (in %) of Liberia in 1981 to that in 1982?
Offer a very short reply. 0.93. What is the ratio of the Population in urban agglomerations (in %) of Pakistan in 1981 to that in 1982?
Ensure brevity in your answer.  0.97. What is the ratio of the Population in urban agglomerations (in %) in South Africa in 1981 to that in 1982?
Provide a succinct answer. 0.98. What is the ratio of the Population in urban agglomerations (in %) of Liberia in 1981 to that in 1983?
Ensure brevity in your answer.  0.87. What is the ratio of the Population in urban agglomerations (in %) in Pakistan in 1981 to that in 1983?
Your answer should be compact. 0.94. What is the ratio of the Population in urban agglomerations (in %) in South Africa in 1981 to that in 1983?
Offer a very short reply. 0.95. What is the ratio of the Population in urban agglomerations (in %) in Liberia in 1981 to that in 1984?
Your answer should be compact. 0.78. What is the ratio of the Population in urban agglomerations (in %) in Pakistan in 1981 to that in 1984?
Ensure brevity in your answer.  0.91. What is the ratio of the Population in urban agglomerations (in %) in South Africa in 1981 to that in 1984?
Make the answer very short. 0.93. What is the ratio of the Population in urban agglomerations (in %) in Liberia in 1982 to that in 1983?
Offer a terse response. 0.93. What is the ratio of the Population in urban agglomerations (in %) of Pakistan in 1982 to that in 1983?
Your response must be concise. 0.97. What is the ratio of the Population in urban agglomerations (in %) in South Africa in 1982 to that in 1983?
Your response must be concise. 0.98. What is the ratio of the Population in urban agglomerations (in %) in Liberia in 1982 to that in 1984?
Ensure brevity in your answer.  0.84. What is the ratio of the Population in urban agglomerations (in %) in Pakistan in 1982 to that in 1984?
Provide a short and direct response. 0.94. What is the ratio of the Population in urban agglomerations (in %) in South Africa in 1982 to that in 1984?
Your answer should be compact. 0.95. What is the ratio of the Population in urban agglomerations (in %) in Liberia in 1983 to that in 1984?
Your answer should be very brief. 0.9. What is the ratio of the Population in urban agglomerations (in %) of Pakistan in 1983 to that in 1984?
Offer a very short reply. 0.97. What is the ratio of the Population in urban agglomerations (in %) of South Africa in 1983 to that in 1984?
Your answer should be compact. 0.98. What is the difference between the highest and the second highest Population in urban agglomerations (in %) in Liberia?
Your response must be concise. 4.28e+04. What is the difference between the highest and the second highest Population in urban agglomerations (in %) of Pakistan?
Your answer should be compact. 4.82e+05. What is the difference between the highest and the second highest Population in urban agglomerations (in %) in South Africa?
Your answer should be compact. 2.13e+05. What is the difference between the highest and the lowest Population in urban agglomerations (in %) of Liberia?
Offer a very short reply. 1.85e+05. What is the difference between the highest and the lowest Population in urban agglomerations (in %) in Pakistan?
Offer a terse response. 3.51e+06. What is the difference between the highest and the lowest Population in urban agglomerations (in %) of South Africa?
Make the answer very short. 1.37e+06. 